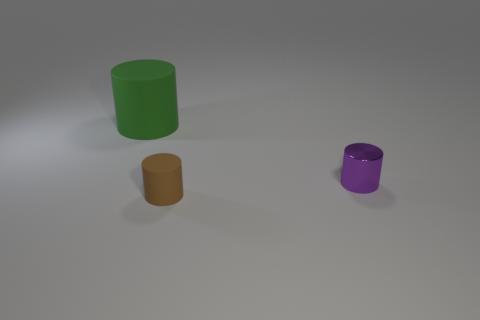Subtract all metallic cylinders. How many cylinders are left? 2 Add 3 small brown things. How many objects exist? 6 Add 2 purple metal cylinders. How many purple metal cylinders are left? 3 Add 3 large shiny cylinders. How many large shiny cylinders exist? 3 Subtract 0 brown spheres. How many objects are left? 3 Subtract all purple cylinders. Subtract all purple balls. How many cylinders are left? 2 Subtract all tiny brown matte cylinders. Subtract all cyan metallic objects. How many objects are left? 2 